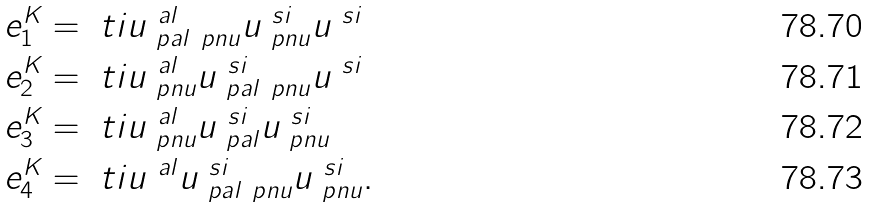Convert formula to latex. <formula><loc_0><loc_0><loc_500><loc_500>e ^ { K } _ { 1 } & = \ t i { u } ^ { \ a l } _ { \ p a l \ p n u } u ^ { \ s i } _ { \ p n u } u ^ { \ s i } \\ e ^ { K } _ { 2 } & = \ t i { u } ^ { \ a l } _ { \ p n u } u ^ { \ s i } _ { \ p a l \ p n u } u ^ { \ s i } \\ e ^ { K } _ { 3 } & = \ t i { u } ^ { \ a l } _ { \ p n u } u ^ { \ s i } _ { \ p a l } u ^ { \ s i } _ { \ p n u } \\ e ^ { K } _ { 4 } & = \ t i { u } ^ { \ a l } u ^ { \ s i } _ { \ p a l \ p n u } u ^ { \ s i } _ { \ p n u } .</formula> 